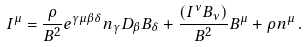<formula> <loc_0><loc_0><loc_500><loc_500>I ^ { \mu } = \frac { \rho } { B ^ { 2 } } e ^ { \gamma \mu \beta \delta } n _ { \gamma } D _ { \beta } B _ { \delta } + \frac { ( I ^ { \nu } B _ { \nu } ) } { B ^ { 2 } } B ^ { \mu } + \rho n ^ { \mu } \, .</formula> 